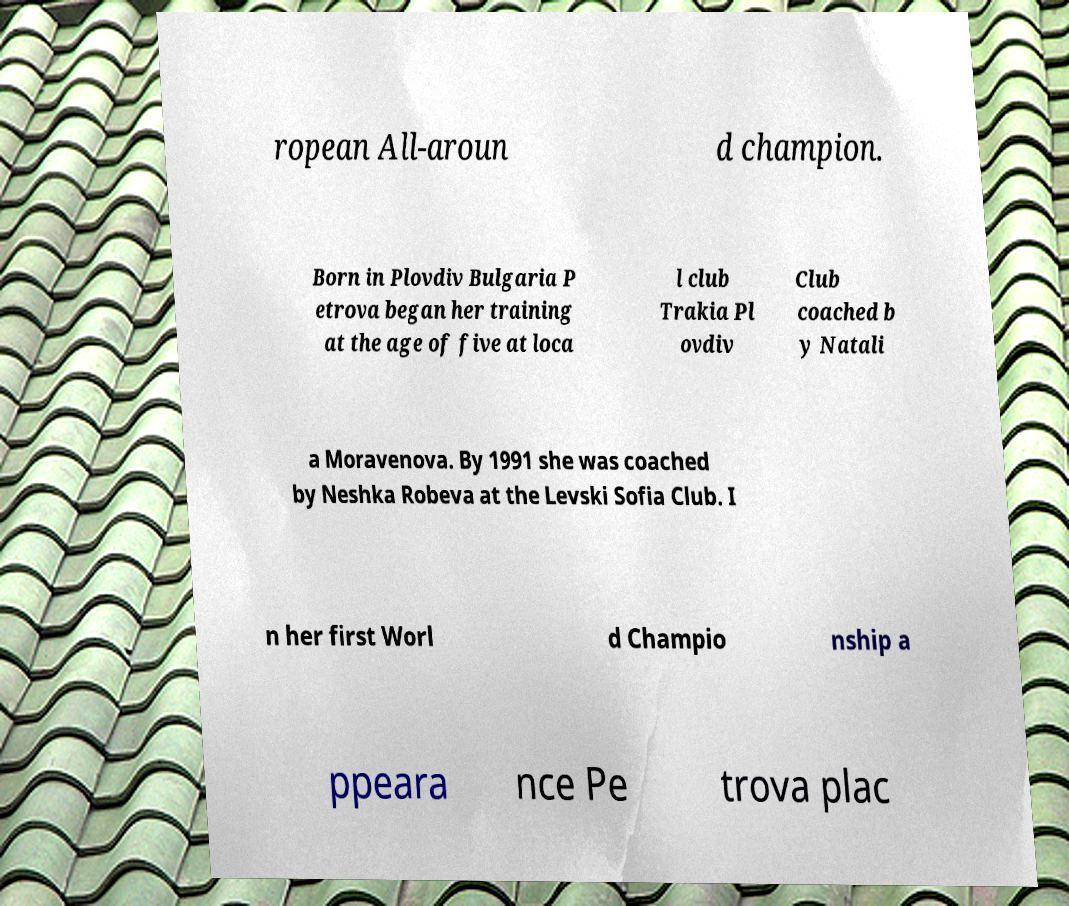Could you extract and type out the text from this image? ropean All-aroun d champion. Born in Plovdiv Bulgaria P etrova began her training at the age of five at loca l club Trakia Pl ovdiv Club coached b y Natali a Moravenova. By 1991 she was coached by Neshka Robeva at the Levski Sofia Club. I n her first Worl d Champio nship a ppeara nce Pe trova plac 